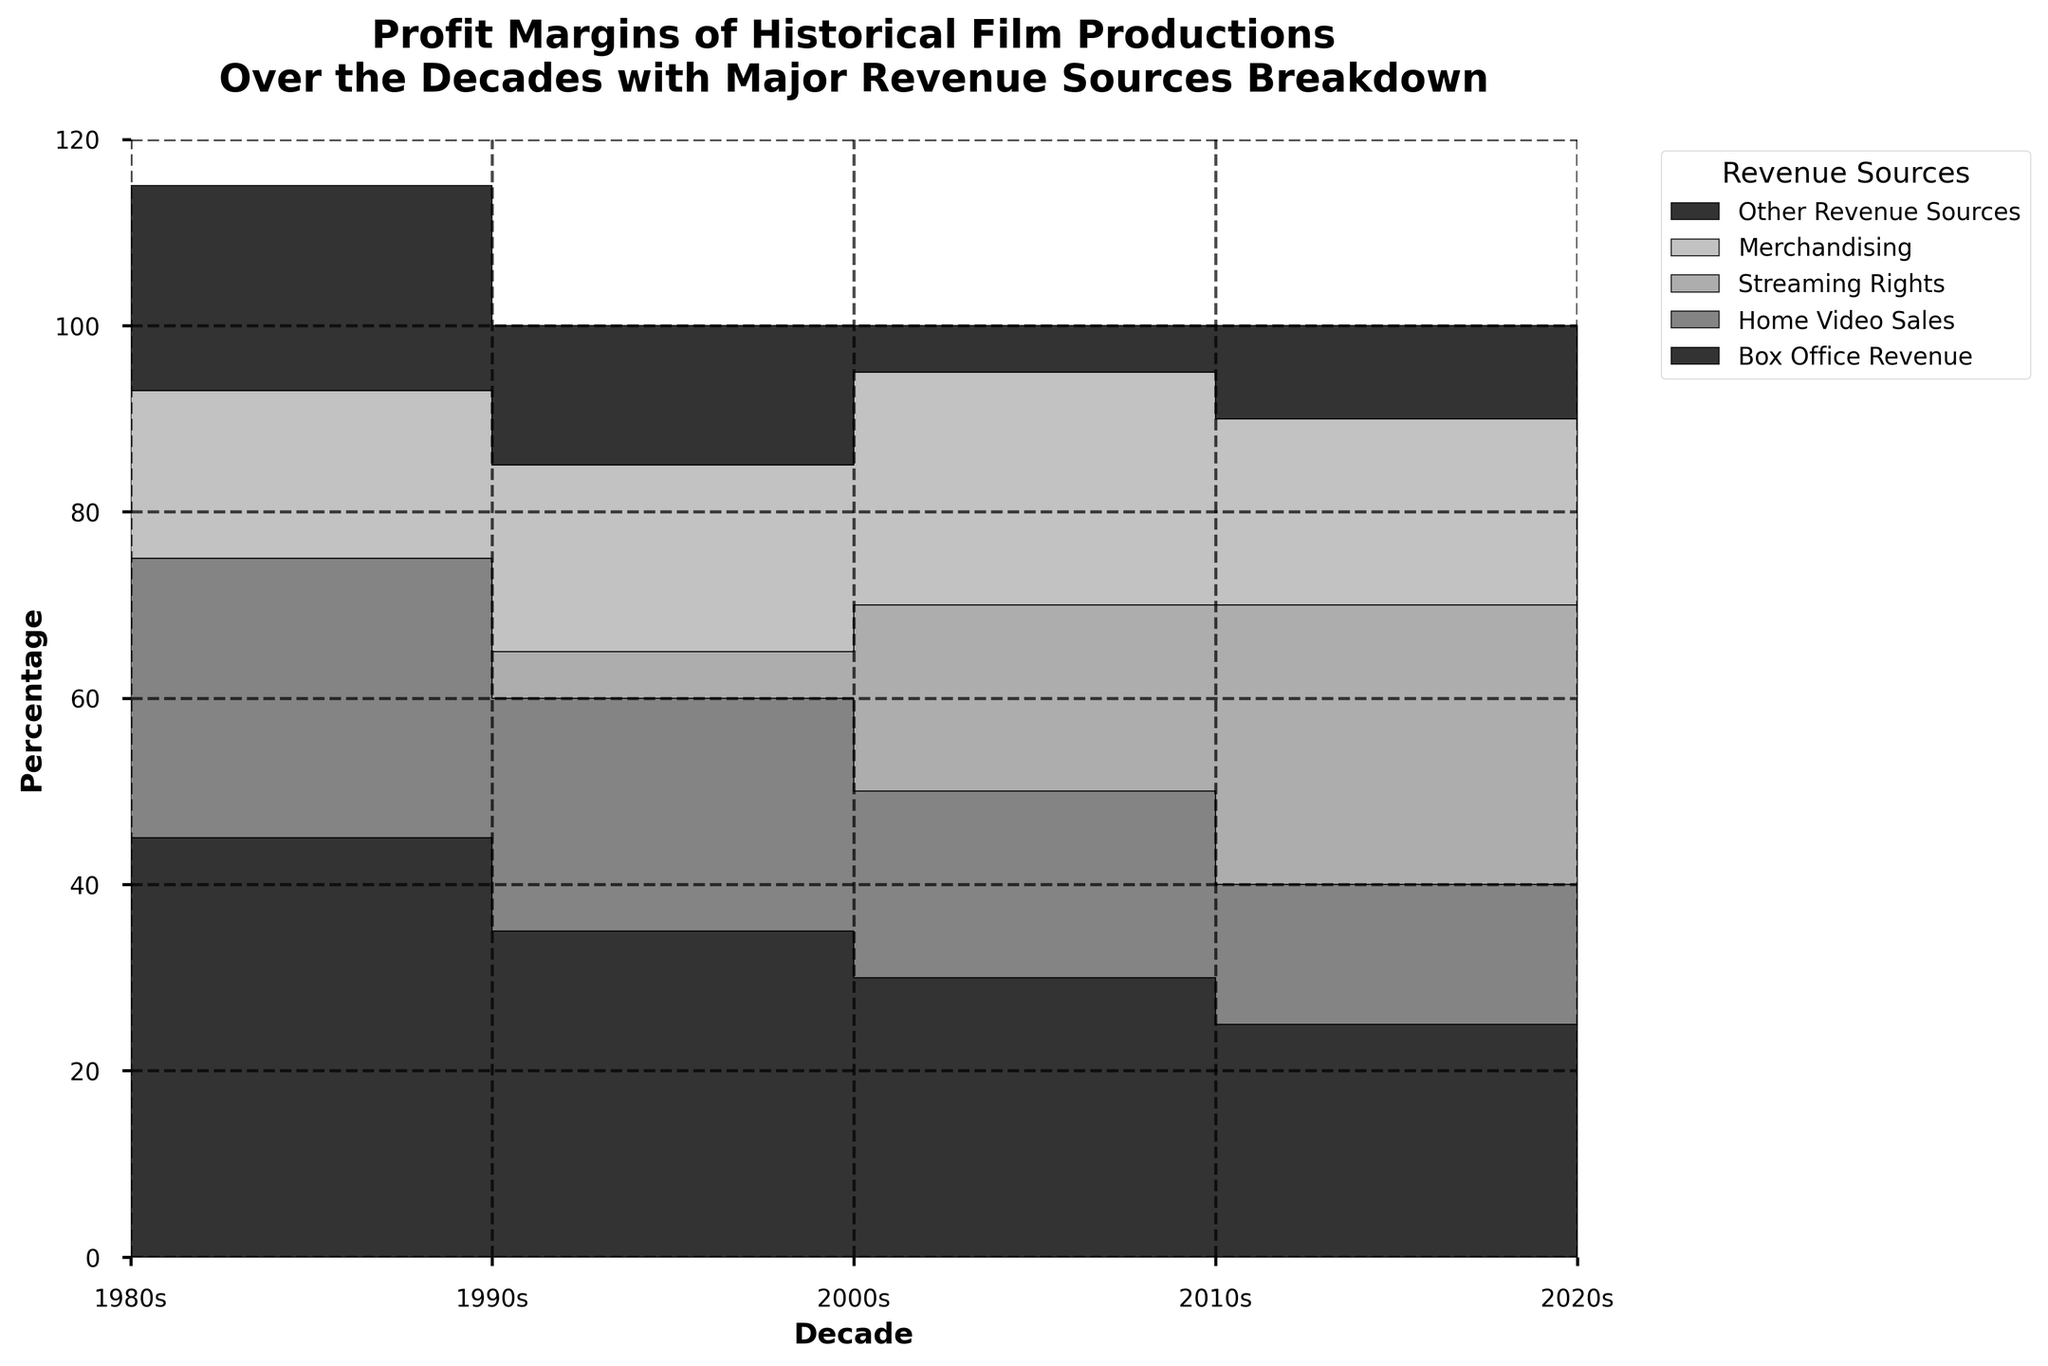What is the title of the chart? The title of the chart is shown at the top of the figure, which reads "Profit Margins of Historical Film Productions Over the Decades with Major Revenue Sources Breakdown".
Answer: Profit Margins of Historical Film Productions Over the Decades with Major Revenue Sources Breakdown Which revenue source saw an increase from the 2000s to the 2010s? By observing the chart, we can see the different segments of the step area chart. The segment representing Streaming Rights shows a noticeable increase from 0 in the 2000s to 20 in the 2010s.
Answer: Streaming Rights How did the total profit margins change from the 1980s to the 2020s? By observing the cumulative height of the step area chart layers, we see a decrease in total profit margins from around 100% in the 1980s to around 100% in the 2020s.
Answer: Decreased Which revenue source consistently declined over the decades? By looking at the areas, we see that the segment representing 'Box Office Revenue' consistently declined from 40 in the 1980s to 25 in the 2020s.
Answer: Box Office Revenue In which decade did Merchandising contribute the most to the profit margins? By observing the chart, the segment for Merchandising is highest in the 2010s, reaching 25%.
Answer: 2010s How much did Other Revenue Sources contribute in the 1990s compared to the 2020s? In the step area chart, the segment for Other Revenue Sources shows 22% in the 1990s and 10% in the 2020s. Subtracting these values, the contribution decreased by 12%.
Answer: Decreased by 12% What was the dominant revenue source in the 2020s? By visually assessing the figure, the 'Streaming Rights' segment appears as the top layer and is the largest segment in the 2020s, at 30%.
Answer: Streaming Rights Did Home Video Sales show any substantial change between the 1980s and 2000s? By comparing the Home Video Sales segment between the 1980s and 2000s, we see that it stayed the same at each 25%.
Answer: No, it stayed the same Compare the contribution of Merchandising in the 1980s and 1990s. From the chart, the segment for Merchandising is 15% in the 1980s and 18% in the 1990s, which means it increased by 3 percentage points.
Answer: Increased by 3 percentage points Which decade had the lowest cumulative profit margins? By observing the total height of all segments in the step area chart, the 2020s have the lowest total height, indicating the lowest cumulative profit margins.
Answer: 2020s 